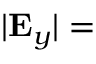Convert formula to latex. <formula><loc_0><loc_0><loc_500><loc_500>| { E } _ { y } | =</formula> 